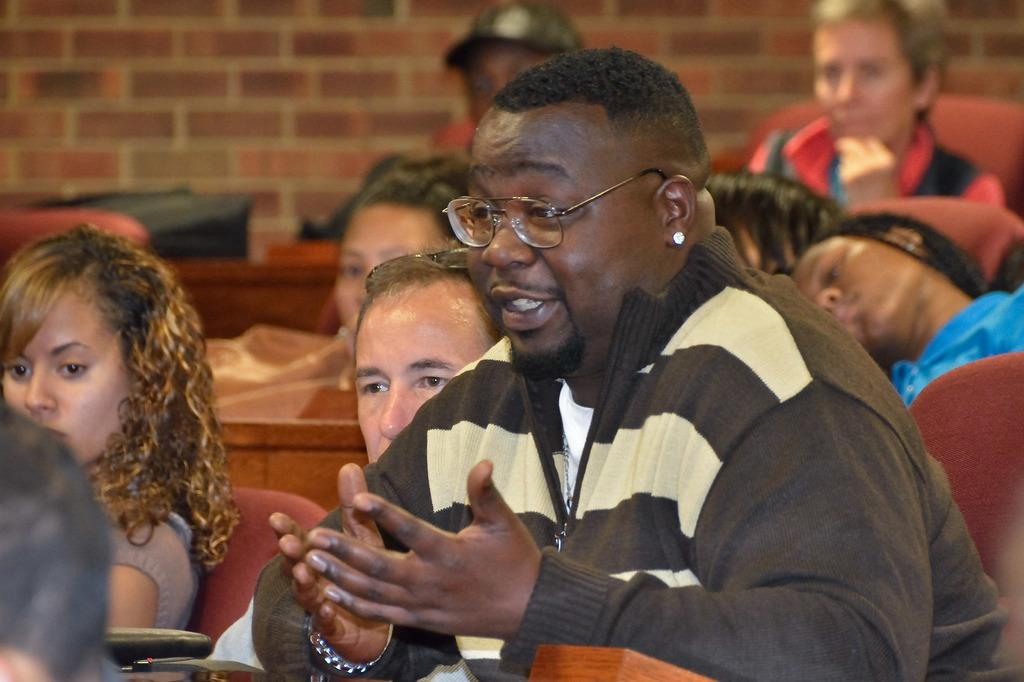What are the people in the image doing? The people in the image are sitting on chairs. Can you describe the appearance of one of the men in the image? One man in the image is wearing spectacles and a jacket. What can be seen in the background of the image? There is a wall visible in the background of the image. How many owls are sitting on the cap of the man in the image? There are no owls present in the image, and the man is not wearing a cap. Can you tell me how many boats are visible in the image? There are no boats visible in the image; it features people sitting on chairs and a wall in the background. 